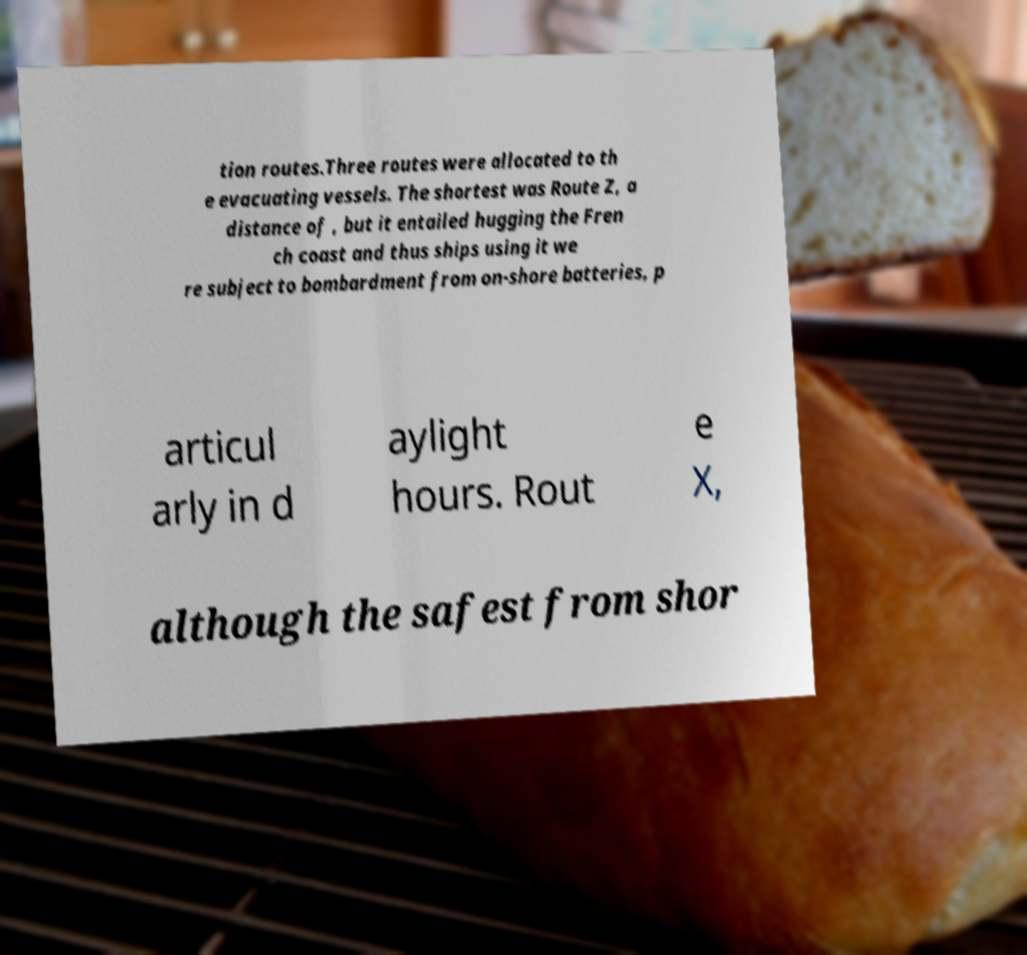Can you accurately transcribe the text from the provided image for me? tion routes.Three routes were allocated to th e evacuating vessels. The shortest was Route Z, a distance of , but it entailed hugging the Fren ch coast and thus ships using it we re subject to bombardment from on-shore batteries, p articul arly in d aylight hours. Rout e X, although the safest from shor 